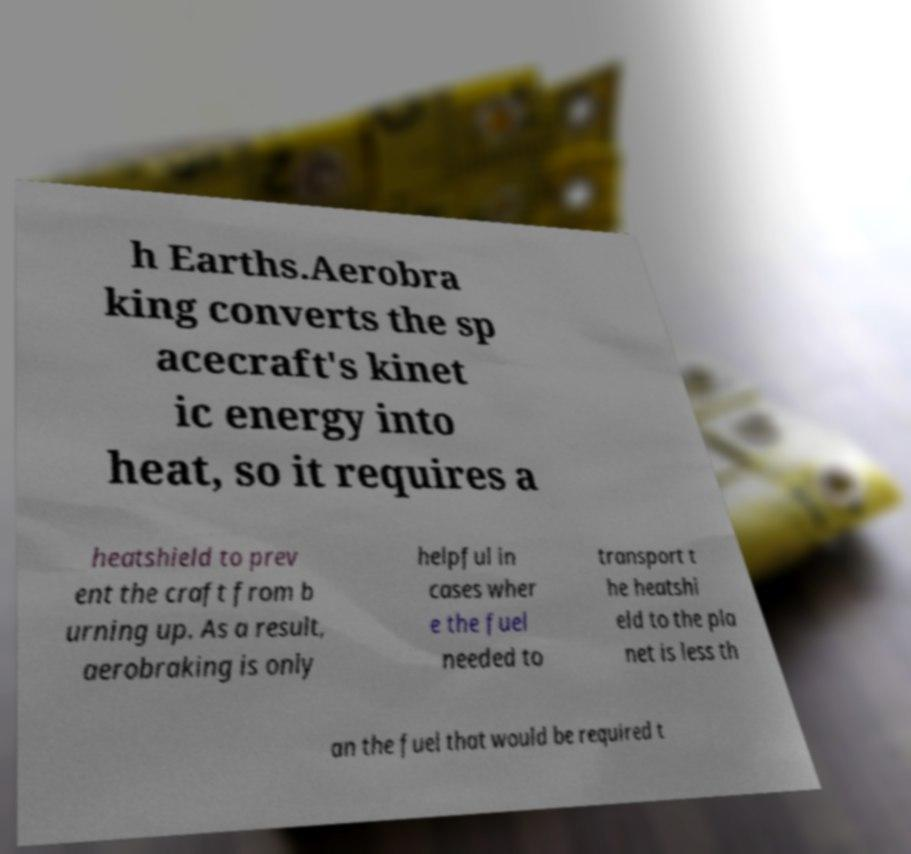Please read and relay the text visible in this image. What does it say? h Earths.Aerobra king converts the sp acecraft's kinet ic energy into heat, so it requires a heatshield to prev ent the craft from b urning up. As a result, aerobraking is only helpful in cases wher e the fuel needed to transport t he heatshi eld to the pla net is less th an the fuel that would be required t 